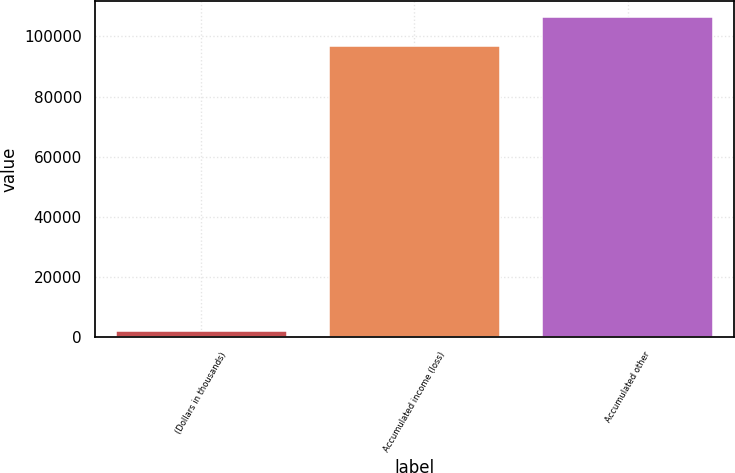Convert chart to OTSL. <chart><loc_0><loc_0><loc_500><loc_500><bar_chart><fcel>(Dollars in thousands)<fcel>Accumulated income (loss)<fcel>Accumulated other<nl><fcel>2016<fcel>96965<fcel>106460<nl></chart> 